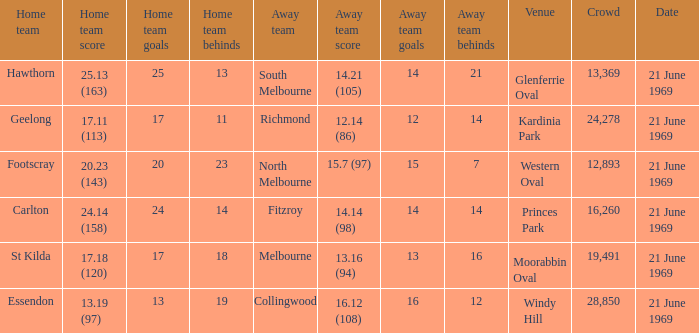When was there a game at Kardinia Park? 21 June 1969. 